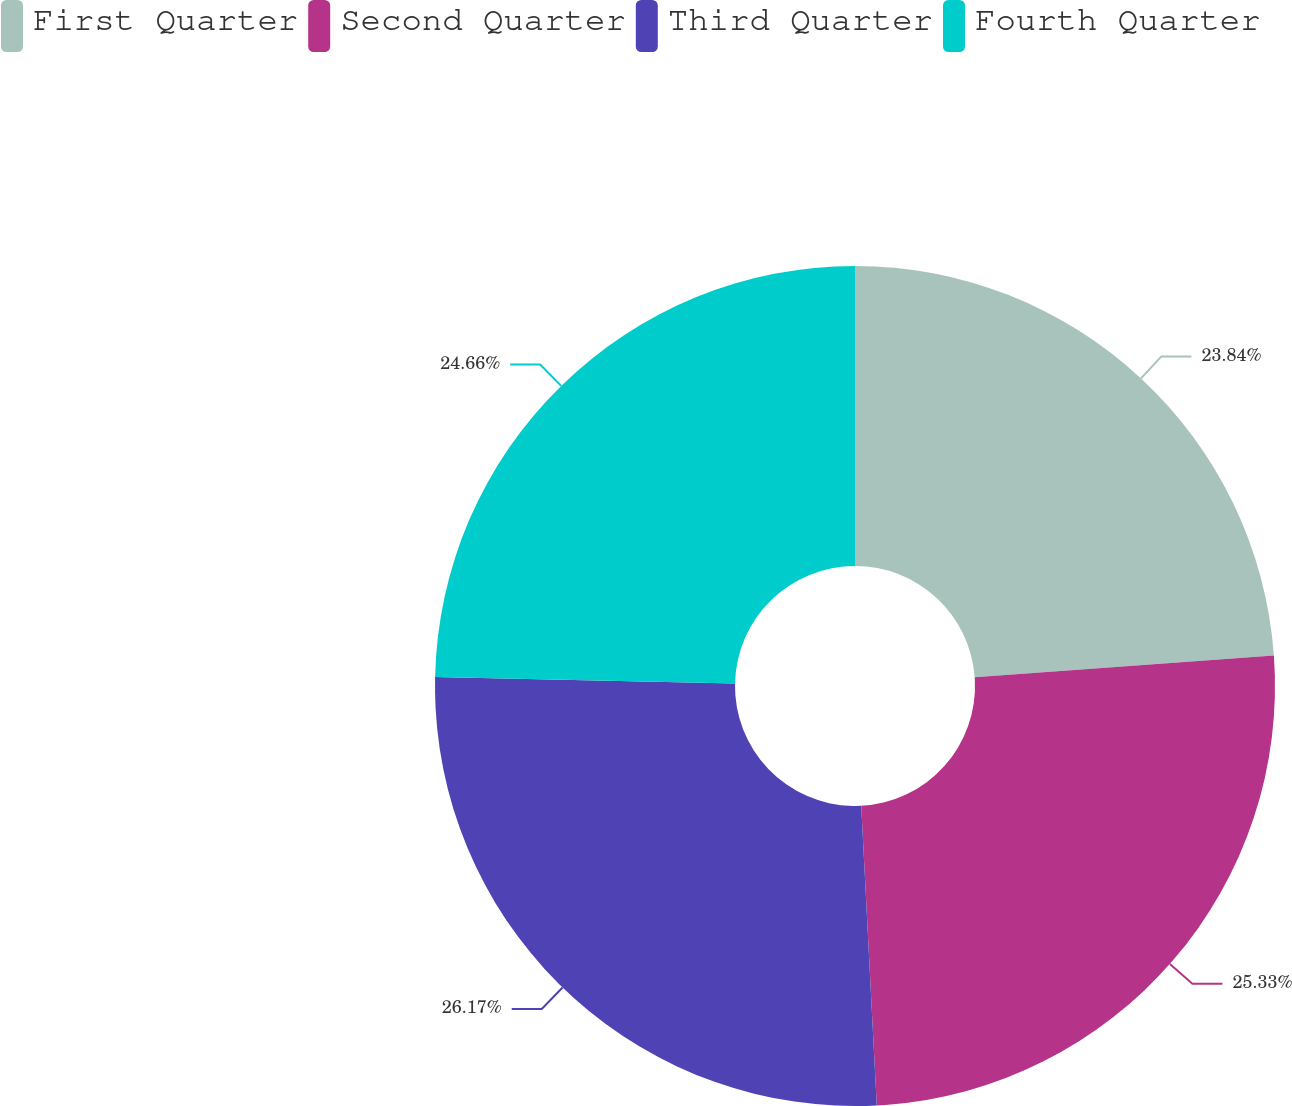<chart> <loc_0><loc_0><loc_500><loc_500><pie_chart><fcel>First Quarter<fcel>Second Quarter<fcel>Third Quarter<fcel>Fourth Quarter<nl><fcel>23.84%<fcel>25.33%<fcel>26.16%<fcel>24.66%<nl></chart> 